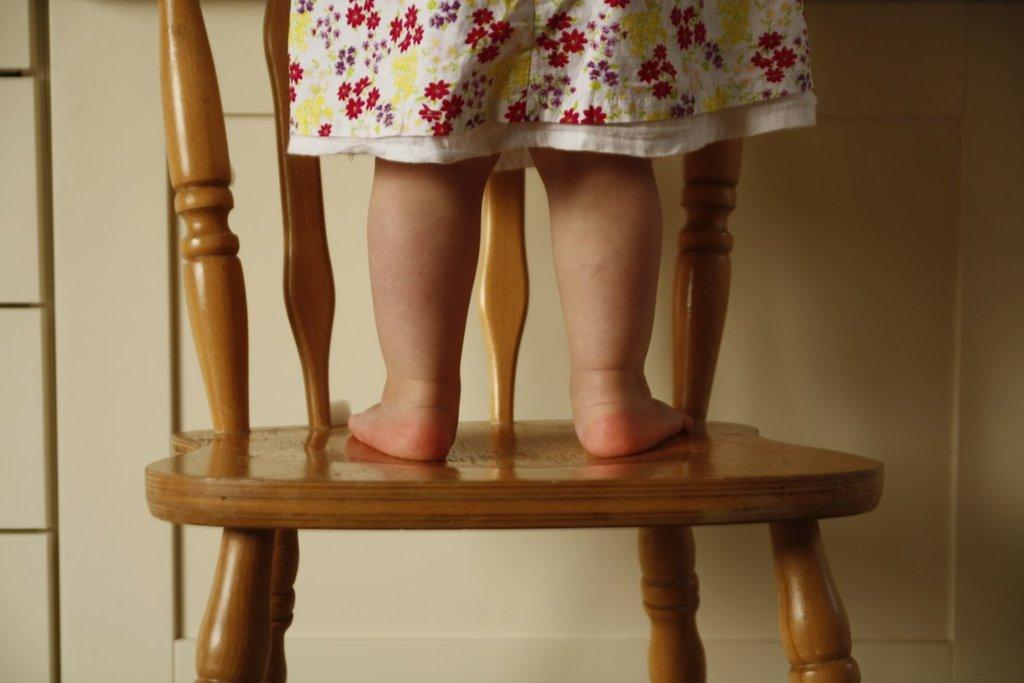Who is the main subject in the image? There is a girl in the image. What is the girl doing in the image? The girl is standing on a chair. What can be seen in the background of the image? There is a cupboard or door in the background of the image. What type of cloud can be seen in the image? There is no cloud present in the image; it is an indoor scene with a girl standing on a chair and a cupboard or door in the background. 